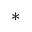<formula> <loc_0><loc_0><loc_500><loc_500>^ { \ast }</formula> 